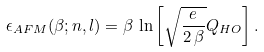Convert formula to latex. <formula><loc_0><loc_0><loc_500><loc_500>\epsilon _ { A F M } ( \beta ; n , l ) = \beta \, \ln \left [ \sqrt { \frac { e } { 2 \, \beta } } Q _ { H O } \right ] .</formula> 